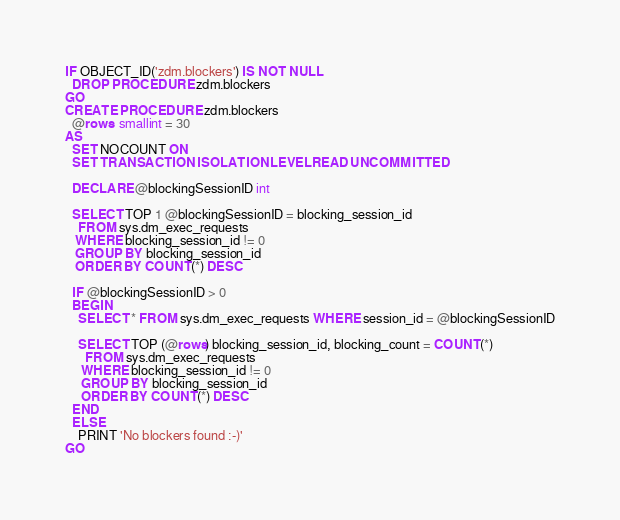<code> <loc_0><loc_0><loc_500><loc_500><_SQL_>
IF OBJECT_ID('zdm.blockers') IS NOT NULL
  DROP PROCEDURE zdm.blockers
GO
CREATE PROCEDURE zdm.blockers
  @rows  smallint = 30
AS
  SET NOCOUNT ON
  SET TRANSACTION ISOLATION LEVEL READ UNCOMMITTED

  DECLARE @blockingSessionID int

  SELECT TOP 1 @blockingSessionID = blocking_session_id 
    FROM sys.dm_exec_requests 
   WHERE blocking_session_id != 0
   GROUP BY blocking_session_id 
   ORDER BY COUNT(*) DESC

  IF @blockingSessionID > 0
  BEGIN
    SELECT * FROM sys.dm_exec_requests WHERE session_id = @blockingSessionID

    SELECT TOP (@rows) blocking_session_id, blocking_count = COUNT(*)
      FROM sys.dm_exec_requests
     WHERE blocking_session_id != 0
     GROUP BY blocking_session_id
     ORDER BY COUNT(*) DESC
  END
  ELSE
    PRINT 'No blockers found :-)'
GO
</code> 